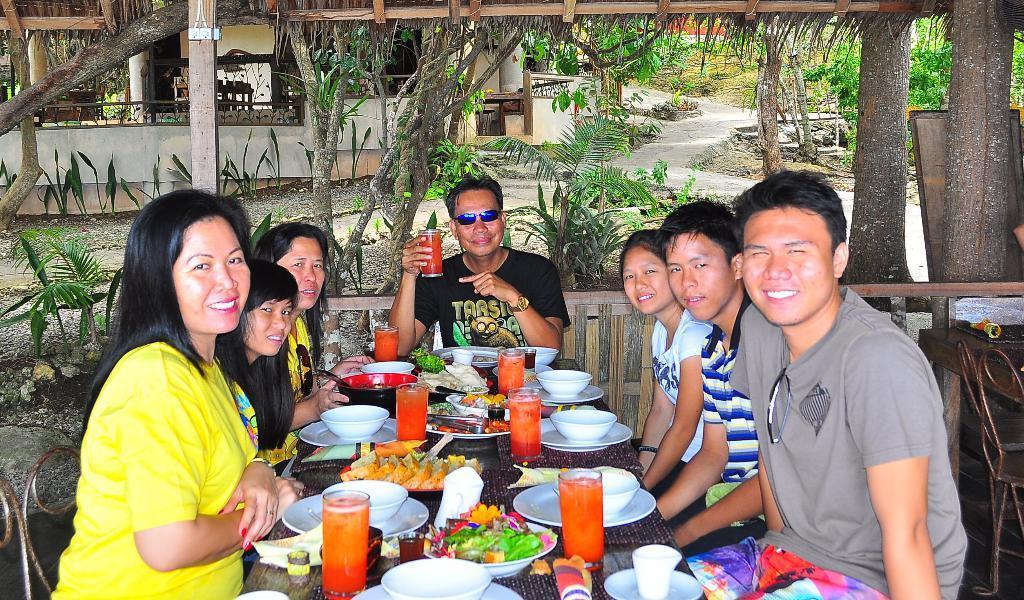Please provide a concise description of this image. In this picture we can see a group of people sitting in front of a dining table, we can see a glass of drink and some of the plates here and glasses, we can see some bowls here, there is a food placed on a dining table, in the background we can see house and also we can see some trees here. 